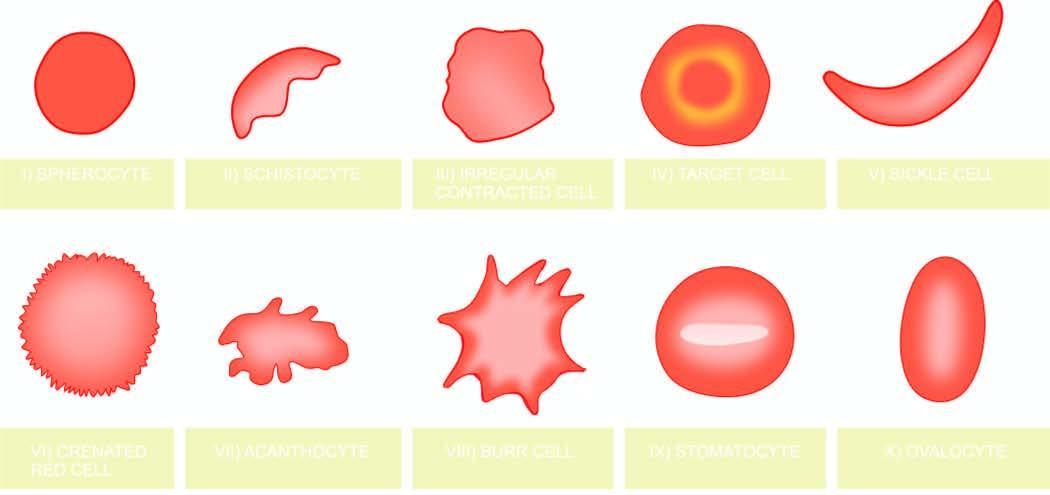what do the serial numbers in the illustrations correspond?
Answer the question using a single word or phrase. The order in which they are described in the text 